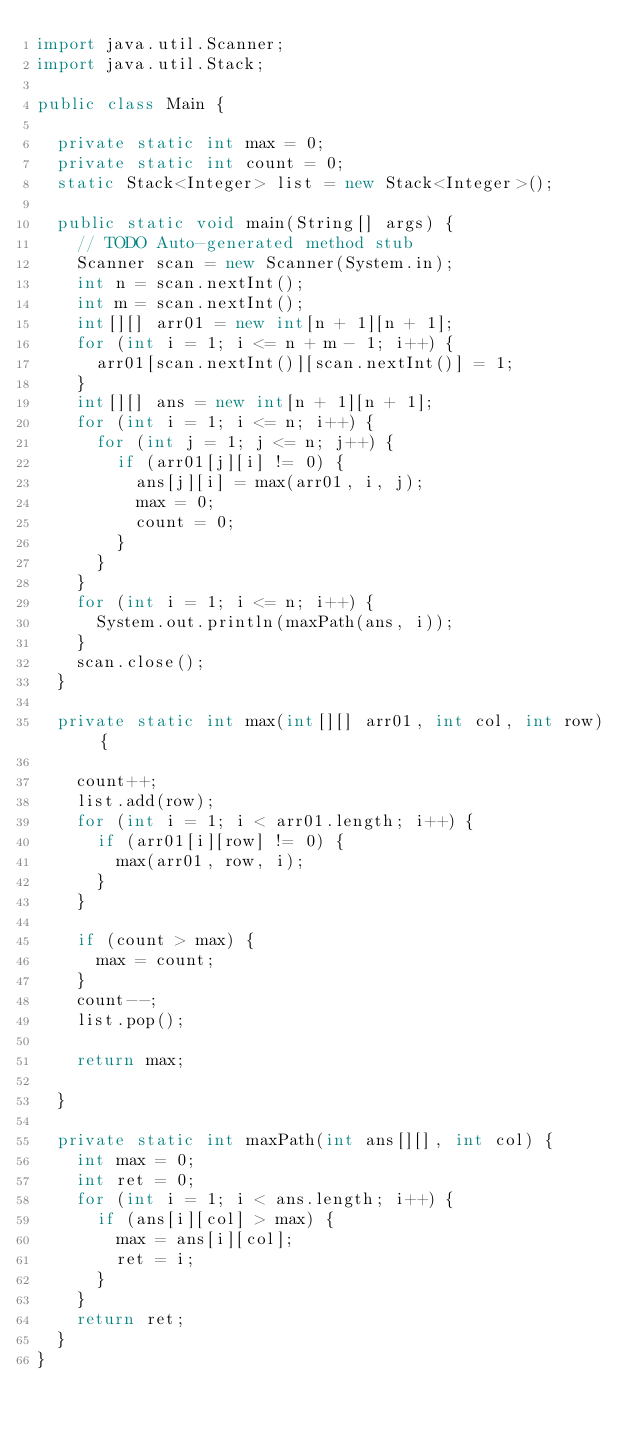Convert code to text. <code><loc_0><loc_0><loc_500><loc_500><_Java_>import java.util.Scanner;
import java.util.Stack;

public class Main {

	private static int max = 0;
	private static int count = 0;
	static Stack<Integer> list = new Stack<Integer>();

	public static void main(String[] args) {
		// TODO Auto-generated method stub
		Scanner scan = new Scanner(System.in);
		int n = scan.nextInt();
		int m = scan.nextInt();
		int[][] arr01 = new int[n + 1][n + 1];
		for (int i = 1; i <= n + m - 1; i++) {
			arr01[scan.nextInt()][scan.nextInt()] = 1;
		}
		int[][] ans = new int[n + 1][n + 1];
		for (int i = 1; i <= n; i++) {
			for (int j = 1; j <= n; j++) {
				if (arr01[j][i] != 0) {
					ans[j][i] = max(arr01, i, j);
					max = 0;
					count = 0;
				}
			}
		}
		for (int i = 1; i <= n; i++) {
			System.out.println(maxPath(ans, i));
		}
		scan.close();
	}

	private static int max(int[][] arr01, int col, int row) {

		count++;
		list.add(row);
		for (int i = 1; i < arr01.length; i++) {
			if (arr01[i][row] != 0) {
				max(arr01, row, i);
			}
		}

		if (count > max) {
			max = count;
		}
		count--;
		list.pop();

		return max;

	}

	private static int maxPath(int ans[][], int col) {
		int max = 0;
		int ret = 0;
		for (int i = 1; i < ans.length; i++) {
			if (ans[i][col] > max) {
				max = ans[i][col];
				ret = i;
			}
		}
		return ret;
	}
}
</code> 